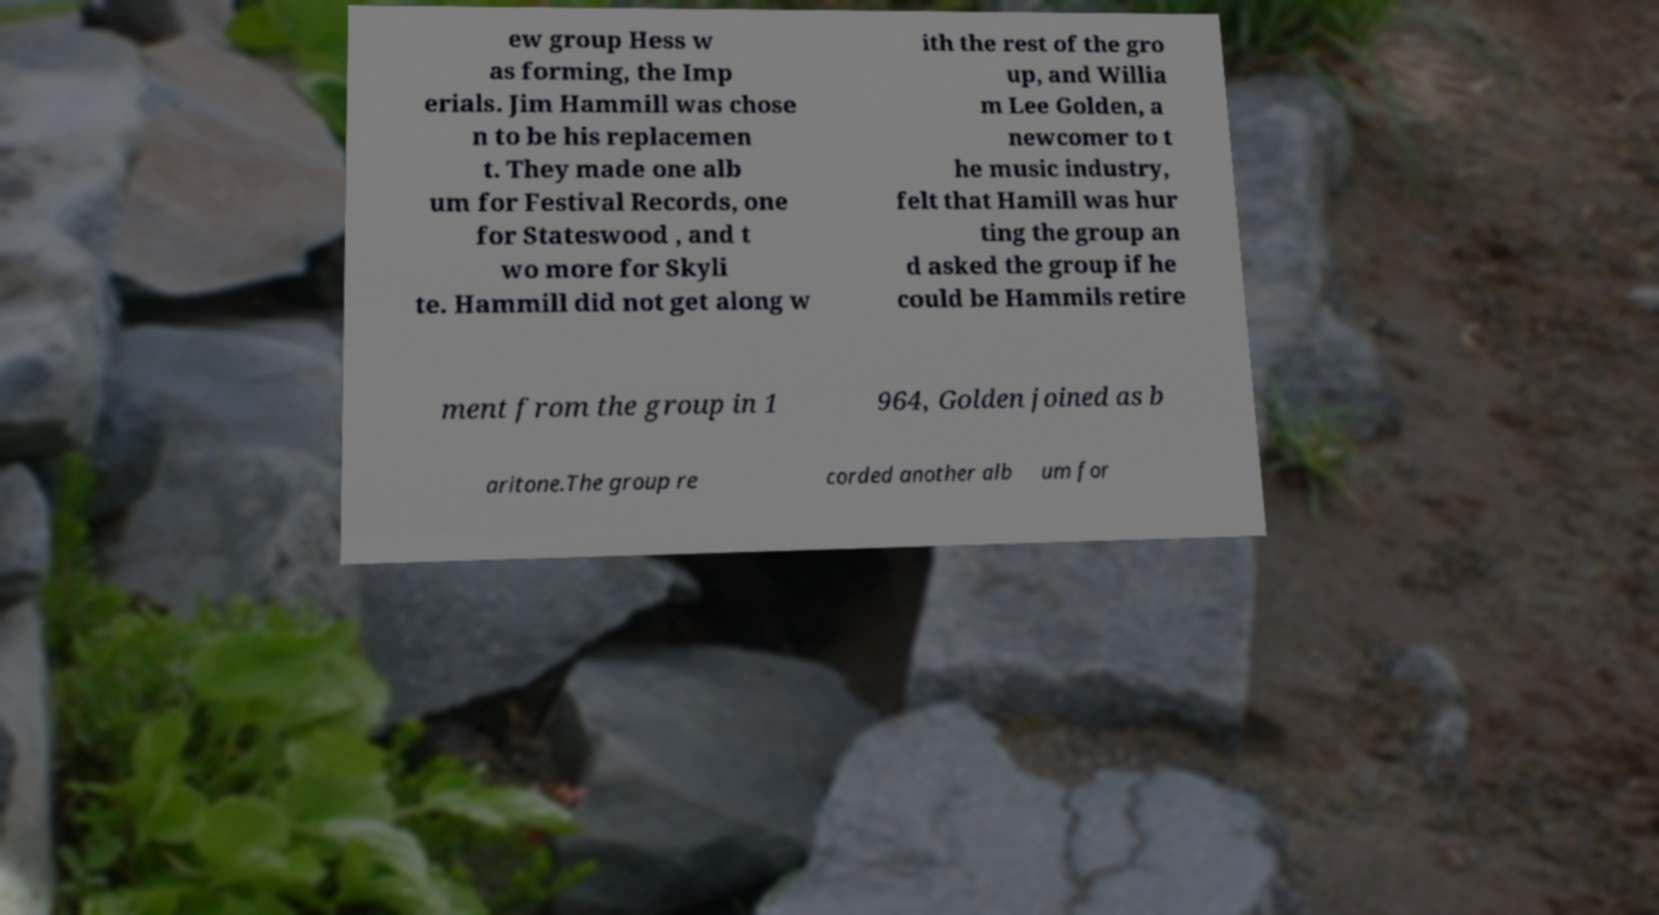For documentation purposes, I need the text within this image transcribed. Could you provide that? ew group Hess w as forming, the Imp erials. Jim Hammill was chose n to be his replacemen t. They made one alb um for Festival Records, one for Stateswood , and t wo more for Skyli te. Hammill did not get along w ith the rest of the gro up, and Willia m Lee Golden, a newcomer to t he music industry, felt that Hamill was hur ting the group an d asked the group if he could be Hammils retire ment from the group in 1 964, Golden joined as b aritone.The group re corded another alb um for 